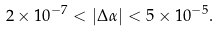Convert formula to latex. <formula><loc_0><loc_0><loc_500><loc_500>2 \times 1 0 ^ { - 7 } < | \Delta \alpha | < 5 \times 1 0 ^ { - 5 } .</formula> 